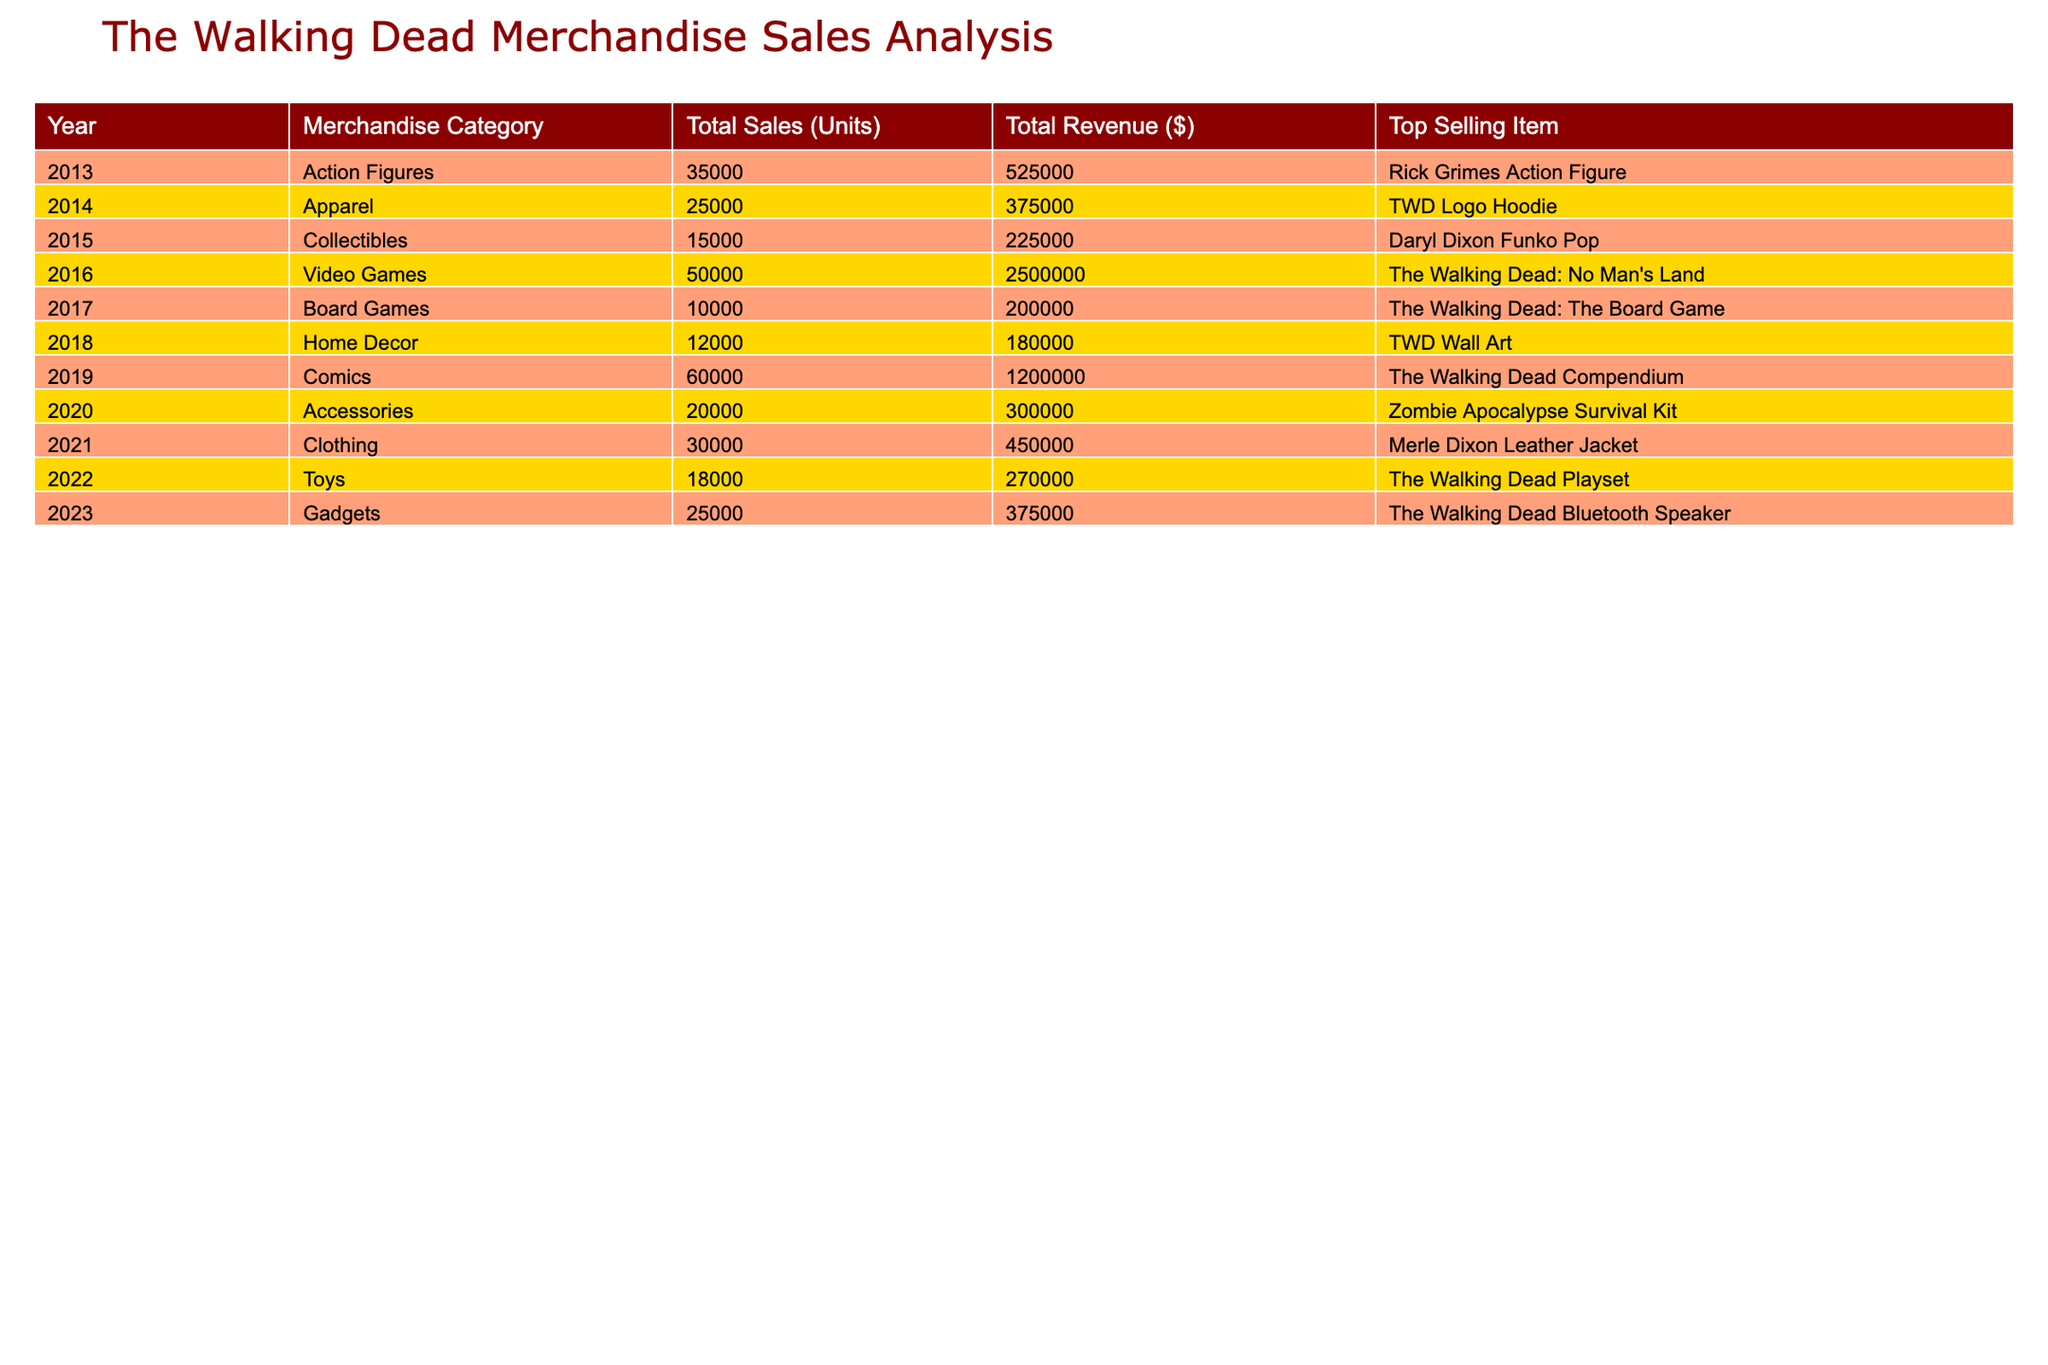What was the total revenue from video games in 2016? The table shows that the total revenue from video games in 2016 is listed under the "Total Revenue ($)" column for that year. It states the revenue is $2,500,000.
Answer: $2,500,000 Which merchandise category had the highest sales units in the year 2019? By looking at the table, the highest sales units in 2019 are for the "Comics" category, where 60,000 units were sold.
Answer: Comics What is the average total sales (units) across all years listed? To find the average, sum all the units sold (35,000 + 25,000 + 15,000 + 50,000 + 10,000 + 12,000 + 60,000 + 20,000 + 30,000 + 18,000 + 25,000) = 355,000 units. There are 11 years represented, so the average is 355,000 / 11 ≈ 32,273.
Answer: 32,273 Did any year report sales for home decor? The table shows that home decor was sold in 2018, confirming that yes, there was sales reported for home decor that year.
Answer: Yes Which year saw the highest revenue from apparel sales? The table indicates that revenue from apparel sales in 2014 amounted to $375,000, which is higher than any other year's apparel revenue. Since apparel is only listed for that one year, it is automatically the highest.
Answer: 2014 What is the difference in total revenue between the top category and the bottom category in 2020? According to the table, in 2020, the highest revenue was $300,000 from "Accessories" and the lowest was $200,000 from "Board Games". The difference is calculated as 300,000 - 200,000 = 100,000.
Answer: $100,000 Which top-selling item contributed to the highest revenue in 2023? The item that contributed to the highest revenue is the "Walking Dead Bluetooth Speaker" in 2023, as it is the only item listed for that year, generating $375,000 in revenue.
Answer: Walking Dead Bluetooth Speaker How many total units were sold from 2015 to 2021? To find the total units sold from 2015 to 2021, add the sales from each respective year: (15,000 + 50,000 + 10,000 + 12,000 + 60,000 + 20,000 + 30,000) = 197,000.
Answer: 197,000 Which category had the lowest sales in terms of units in 2017? The table specifies that "Board Games" had the lowest sales in 2017 with a total of 10,000 units sold.
Answer: Board Games 